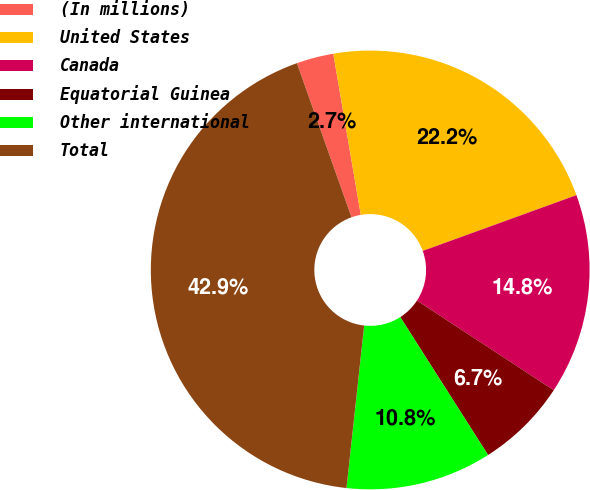<chart> <loc_0><loc_0><loc_500><loc_500><pie_chart><fcel>(In millions)<fcel>United States<fcel>Canada<fcel>Equatorial Guinea<fcel>Other international<fcel>Total<nl><fcel>2.73%<fcel>22.15%<fcel>14.77%<fcel>6.74%<fcel>10.75%<fcel>42.85%<nl></chart> 